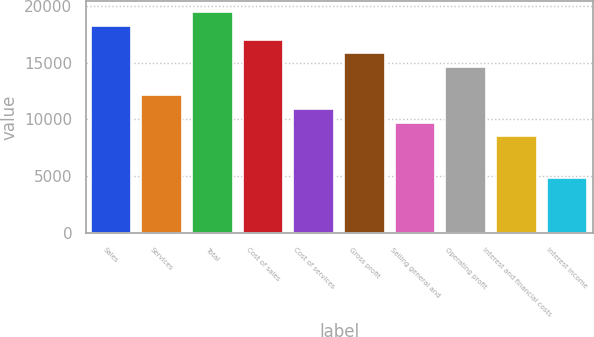Convert chart. <chart><loc_0><loc_0><loc_500><loc_500><bar_chart><fcel>Sales<fcel>Services<fcel>Total<fcel>Cost of sales<fcel>Cost of services<fcel>Gross profit<fcel>Selling general and<fcel>Operating profit<fcel>Interest and financial costs<fcel>Interest income<nl><fcel>18233.8<fcel>12156<fcel>19449.4<fcel>17018.2<fcel>10940.5<fcel>15802.7<fcel>9724.89<fcel>14587.1<fcel>8509.33<fcel>4862.65<nl></chart> 